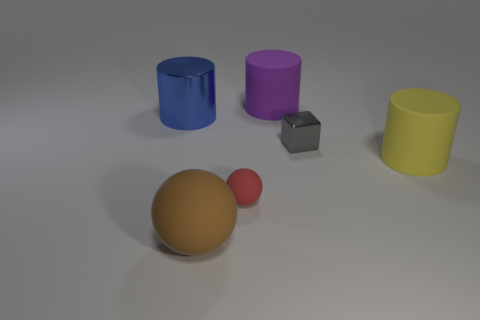Are the large purple cylinder and the cylinder in front of the big blue metal cylinder made of the same material?
Give a very brief answer. Yes. The shiny object right of the large thing in front of the big yellow thing is what shape?
Make the answer very short. Cube. The object that is behind the large yellow rubber cylinder and to the right of the large purple rubber cylinder has what shape?
Keep it short and to the point. Cube. How many objects are either green things or small things behind the large brown thing?
Provide a succinct answer. 2. What material is the other purple object that is the same shape as the big shiny object?
Your answer should be very brief. Rubber. Are there any other things that are the same material as the gray block?
Your answer should be very brief. Yes. The cylinder that is in front of the purple matte object and behind the tiny shiny block is made of what material?
Keep it short and to the point. Metal. How many red matte things are the same shape as the purple rubber object?
Offer a very short reply. 0. The big matte cylinder that is behind the big cylinder in front of the blue thing is what color?
Your response must be concise. Purple. Is the number of large purple objects that are in front of the large rubber ball the same as the number of big metallic things?
Provide a short and direct response. No. 